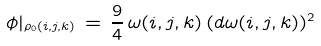<formula> <loc_0><loc_0><loc_500><loc_500>\phi | _ { \rho _ { 0 } ( i , j , k ) } \, = \, \frac { 9 } { 4 } \, \omega ( i , j , k ) \, ( d \omega ( i , j , k ) ) ^ { 2 }</formula> 